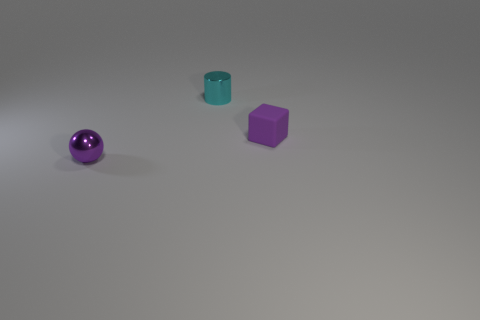What number of objects are both to the left of the purple matte cube and right of the small purple metal sphere?
Keep it short and to the point. 1. Does the shiny object in front of the purple matte block have the same size as the small metallic cylinder?
Keep it short and to the point. Yes. Is there another tiny sphere that has the same color as the ball?
Offer a terse response. No. The purple ball that is the same material as the tiny cyan cylinder is what size?
Offer a very short reply. Small. Is the number of cyan things in front of the purple matte cube greater than the number of metal cylinders left of the small metal sphere?
Your answer should be very brief. No. How many other things are there of the same material as the ball?
Make the answer very short. 1. Is the thing behind the rubber thing made of the same material as the cube?
Your answer should be very brief. No. The purple rubber thing has what shape?
Provide a succinct answer. Cube. Is the number of small cylinders that are left of the tiny shiny ball greater than the number of red metal balls?
Make the answer very short. No. Is there any other thing that has the same shape as the cyan thing?
Offer a very short reply. No. 